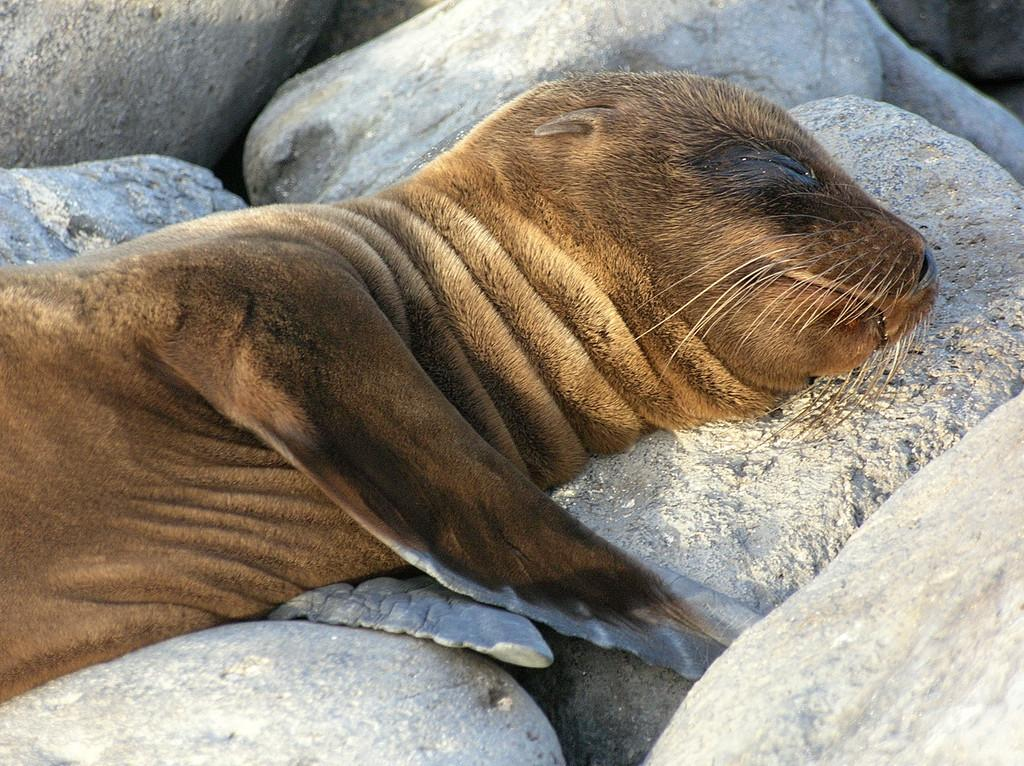What is present at the bottom of the image? There are stones at the bottom of the image. What type of animal is on the stones? There is a seal on the stones. Where is the maid located in the image? There is no maid present in the image. What type of nest can be seen in the image? There is no nest present in the image. 